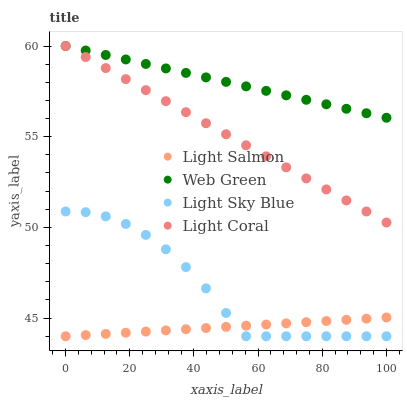Does Light Salmon have the minimum area under the curve?
Answer yes or no. Yes. Does Web Green have the maximum area under the curve?
Answer yes or no. Yes. Does Light Sky Blue have the minimum area under the curve?
Answer yes or no. No. Does Light Sky Blue have the maximum area under the curve?
Answer yes or no. No. Is Light Salmon the smoothest?
Answer yes or no. Yes. Is Light Sky Blue the roughest?
Answer yes or no. Yes. Is Light Sky Blue the smoothest?
Answer yes or no. No. Is Light Salmon the roughest?
Answer yes or no. No. Does Light Salmon have the lowest value?
Answer yes or no. Yes. Does Web Green have the lowest value?
Answer yes or no. No. Does Web Green have the highest value?
Answer yes or no. Yes. Does Light Sky Blue have the highest value?
Answer yes or no. No. Is Light Salmon less than Light Coral?
Answer yes or no. Yes. Is Light Coral greater than Light Salmon?
Answer yes or no. Yes. Does Web Green intersect Light Coral?
Answer yes or no. Yes. Is Web Green less than Light Coral?
Answer yes or no. No. Is Web Green greater than Light Coral?
Answer yes or no. No. Does Light Salmon intersect Light Coral?
Answer yes or no. No. 